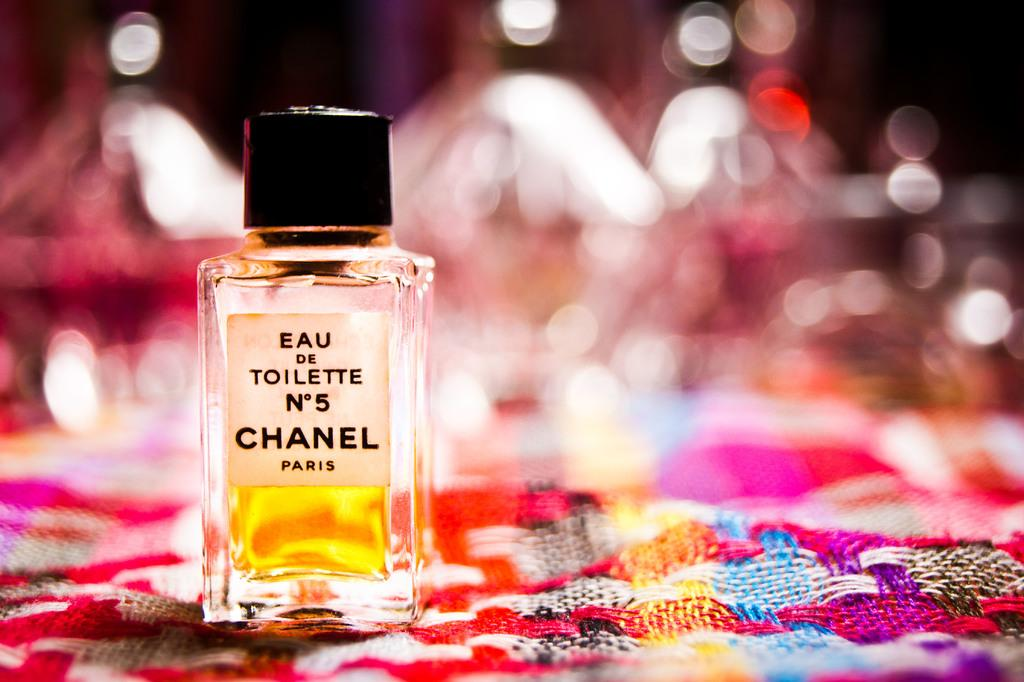<image>
Render a clear and concise summary of the photo. A bottle of Chanel No 5 perfume that is made in Paris. 